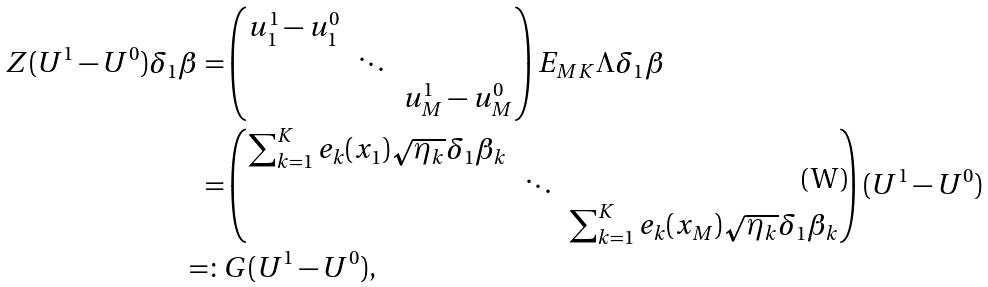Convert formula to latex. <formula><loc_0><loc_0><loc_500><loc_500>Z ( U ^ { 1 } - U ^ { 0 } ) \delta _ { 1 } \beta = & \begin{pmatrix} u _ { 1 } ^ { 1 } - u _ { 1 } ^ { 0 } & & \\ & \ddots & \\ & & u _ { M } ^ { 1 } - u _ { M } ^ { 0 } \end{pmatrix} E _ { M K } \Lambda \delta _ { 1 } \beta \\ = & \begin{pmatrix} \sum _ { k = 1 } ^ { K } e _ { k } ( x _ { 1 } ) \sqrt { \eta _ { k } } \delta _ { 1 } \beta _ { k } & & \\ & \ddots & \\ & & \sum _ { k = 1 } ^ { K } e _ { k } ( x _ { M } ) \sqrt { \eta _ { k } } \delta _ { 1 } \beta _ { k } \end{pmatrix} ( U ^ { 1 } - U ^ { 0 } ) \\ = \colon & G ( U ^ { 1 } - U ^ { 0 } ) ,</formula> 